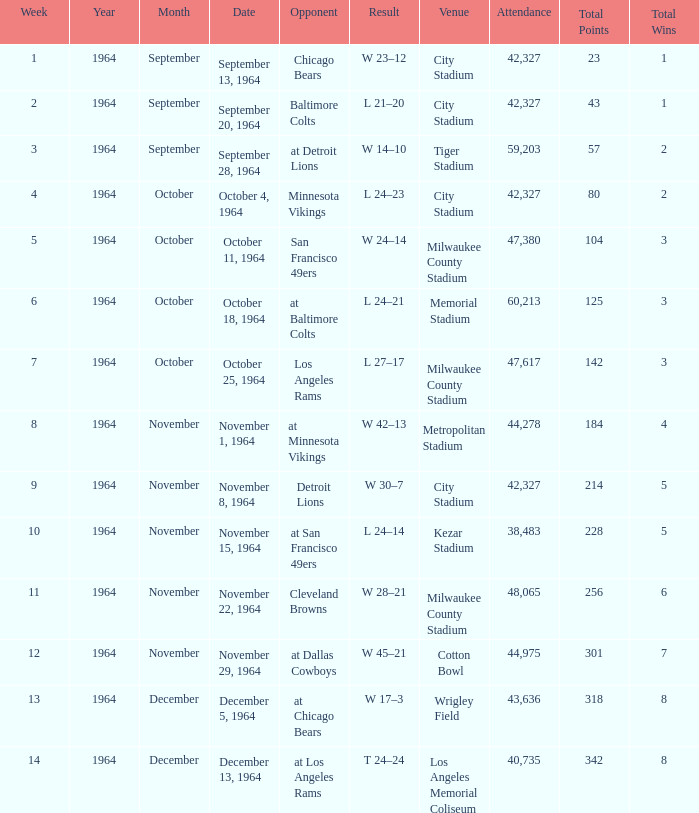What is the average attendance at a week 4 game? 42327.0. 